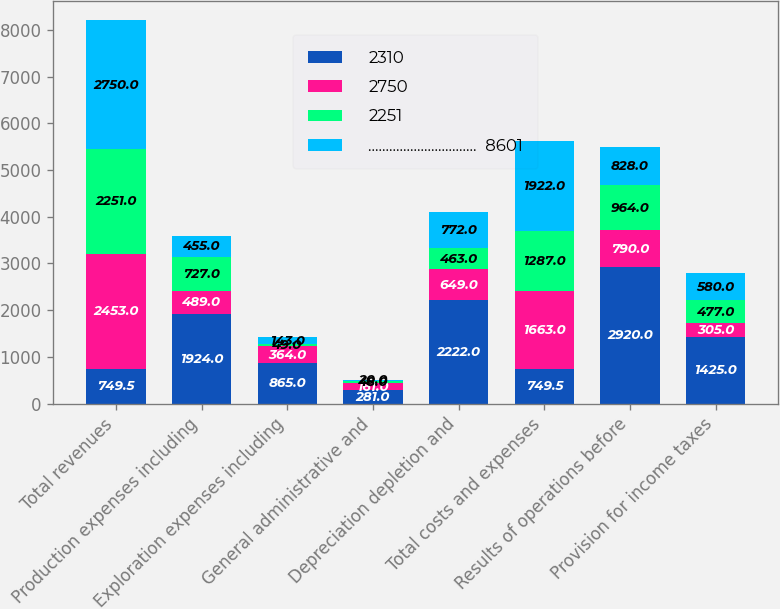<chart> <loc_0><loc_0><loc_500><loc_500><stacked_bar_chart><ecel><fcel>Total revenues<fcel>Production expenses including<fcel>Exploration expenses including<fcel>General administrative and<fcel>Depreciation depletion and<fcel>Total costs and expenses<fcel>Results of operations before<fcel>Provision for income taxes<nl><fcel>2310<fcel>749.5<fcel>1924<fcel>865<fcel>281<fcel>2222<fcel>749.5<fcel>2920<fcel>1425<nl><fcel>2750<fcel>2453<fcel>489<fcel>364<fcel>161<fcel>649<fcel>1663<fcel>790<fcel>305<nl><fcel>2251<fcel>2251<fcel>727<fcel>49<fcel>48<fcel>463<fcel>1287<fcel>964<fcel>477<nl><fcel>...............................  8601<fcel>2750<fcel>455<fcel>143<fcel>20<fcel>772<fcel>1922<fcel>828<fcel>580<nl></chart> 